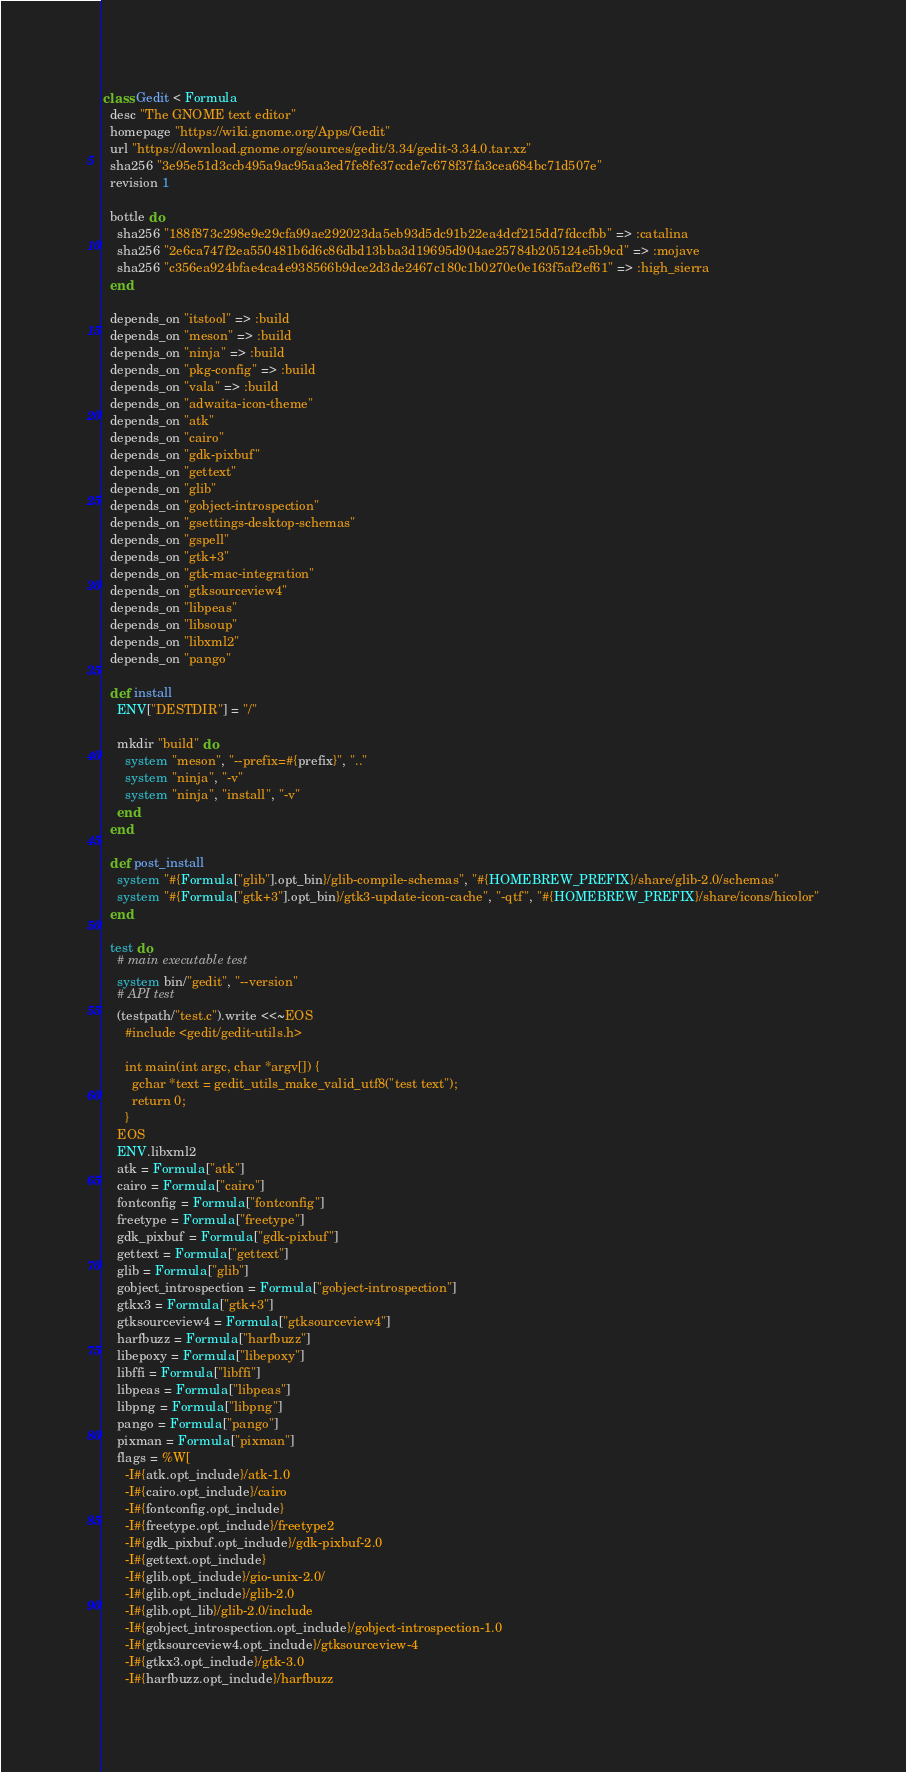<code> <loc_0><loc_0><loc_500><loc_500><_Ruby_>class Gedit < Formula
  desc "The GNOME text editor"
  homepage "https://wiki.gnome.org/Apps/Gedit"
  url "https://download.gnome.org/sources/gedit/3.34/gedit-3.34.0.tar.xz"
  sha256 "3e95e51d3ccb495a9ac95aa3ed7fe8fe37ccde7c678f37fa3cea684bc71d507e"
  revision 1

  bottle do
    sha256 "188f873c298e9e29cfa99ae292023da5eb93d5dc91b22ea4dcf215dd7fdccfbb" => :catalina
    sha256 "2e6ca747f2ea550481b6d6c86dbd13bba3d19695d904ae25784b205124e5b9cd" => :mojave
    sha256 "c356ea924bfae4ca4e938566b9dce2d3de2467c180c1b0270e0e163f5af2ef61" => :high_sierra
  end

  depends_on "itstool" => :build
  depends_on "meson" => :build
  depends_on "ninja" => :build
  depends_on "pkg-config" => :build
  depends_on "vala" => :build
  depends_on "adwaita-icon-theme"
  depends_on "atk"
  depends_on "cairo"
  depends_on "gdk-pixbuf"
  depends_on "gettext"
  depends_on "glib"
  depends_on "gobject-introspection"
  depends_on "gsettings-desktop-schemas"
  depends_on "gspell"
  depends_on "gtk+3"
  depends_on "gtk-mac-integration"
  depends_on "gtksourceview4"
  depends_on "libpeas"
  depends_on "libsoup"
  depends_on "libxml2"
  depends_on "pango"

  def install
    ENV["DESTDIR"] = "/"

    mkdir "build" do
      system "meson", "--prefix=#{prefix}", ".."
      system "ninja", "-v"
      system "ninja", "install", "-v"
    end
  end

  def post_install
    system "#{Formula["glib"].opt_bin}/glib-compile-schemas", "#{HOMEBREW_PREFIX}/share/glib-2.0/schemas"
    system "#{Formula["gtk+3"].opt_bin}/gtk3-update-icon-cache", "-qtf", "#{HOMEBREW_PREFIX}/share/icons/hicolor"
  end

  test do
    # main executable test
    system bin/"gedit", "--version"
    # API test
    (testpath/"test.c").write <<~EOS
      #include <gedit/gedit-utils.h>

      int main(int argc, char *argv[]) {
        gchar *text = gedit_utils_make_valid_utf8("test text");
        return 0;
      }
    EOS
    ENV.libxml2
    atk = Formula["atk"]
    cairo = Formula["cairo"]
    fontconfig = Formula["fontconfig"]
    freetype = Formula["freetype"]
    gdk_pixbuf = Formula["gdk-pixbuf"]
    gettext = Formula["gettext"]
    glib = Formula["glib"]
    gobject_introspection = Formula["gobject-introspection"]
    gtkx3 = Formula["gtk+3"]
    gtksourceview4 = Formula["gtksourceview4"]
    harfbuzz = Formula["harfbuzz"]
    libepoxy = Formula["libepoxy"]
    libffi = Formula["libffi"]
    libpeas = Formula["libpeas"]
    libpng = Formula["libpng"]
    pango = Formula["pango"]
    pixman = Formula["pixman"]
    flags = %W[
      -I#{atk.opt_include}/atk-1.0
      -I#{cairo.opt_include}/cairo
      -I#{fontconfig.opt_include}
      -I#{freetype.opt_include}/freetype2
      -I#{gdk_pixbuf.opt_include}/gdk-pixbuf-2.0
      -I#{gettext.opt_include}
      -I#{glib.opt_include}/gio-unix-2.0/
      -I#{glib.opt_include}/glib-2.0
      -I#{glib.opt_lib}/glib-2.0/include
      -I#{gobject_introspection.opt_include}/gobject-introspection-1.0
      -I#{gtksourceview4.opt_include}/gtksourceview-4
      -I#{gtkx3.opt_include}/gtk-3.0
      -I#{harfbuzz.opt_include}/harfbuzz</code> 